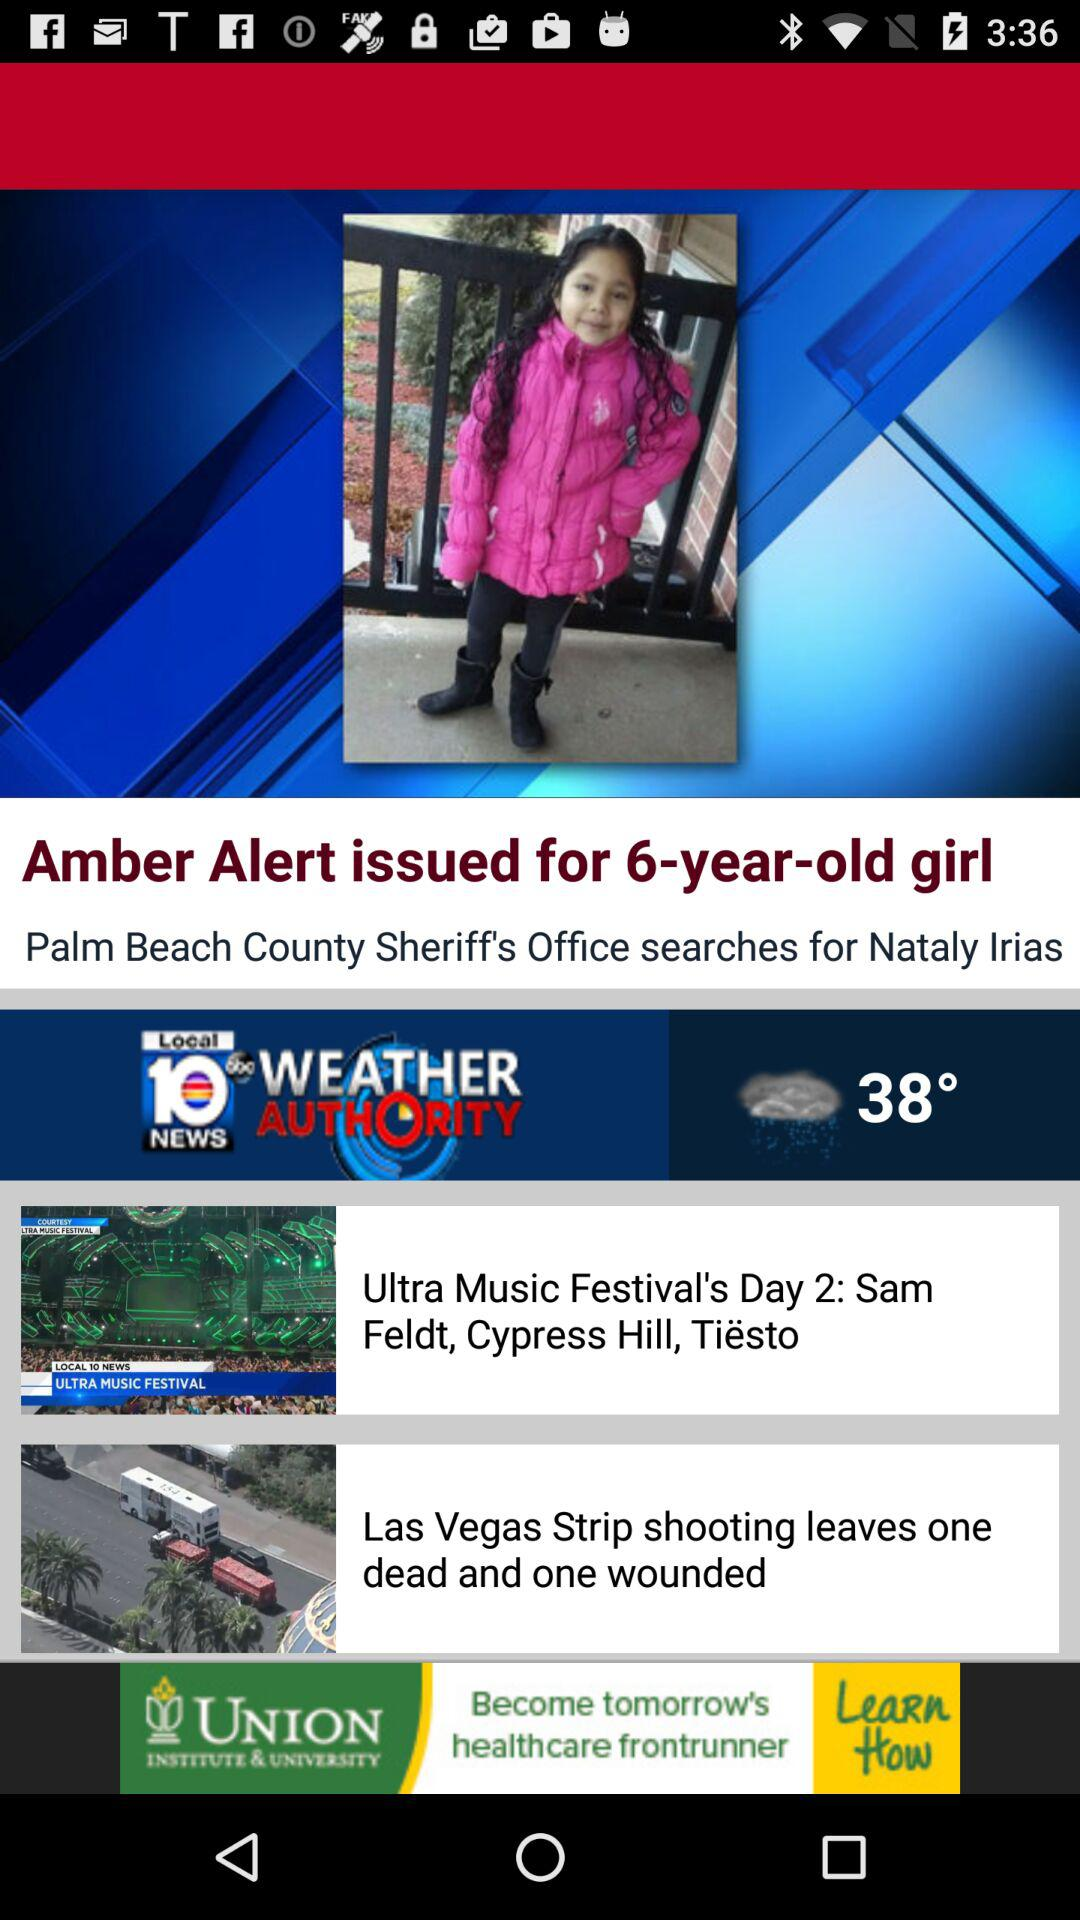What is the temperature? The temperature is 38°. 